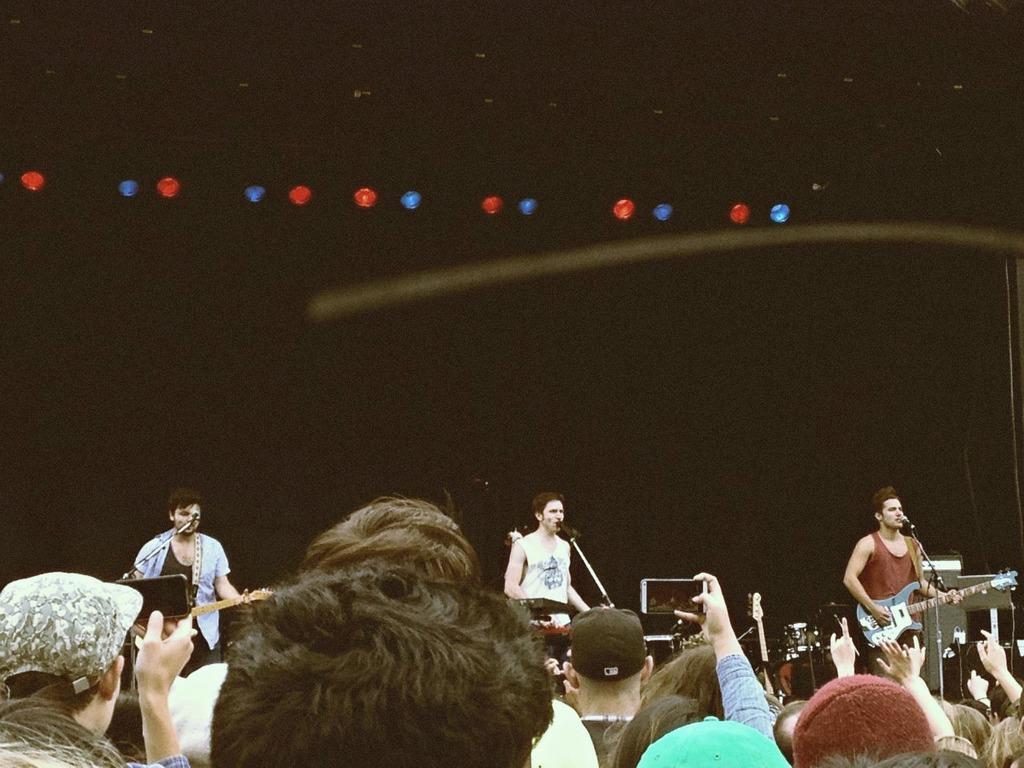In one or two sentences, can you explain what this image depicts? A rock band is performing on the stage. There is man singing in the center and two men on either side playing guitar. There are lights on the top. The crowd is in the front. 